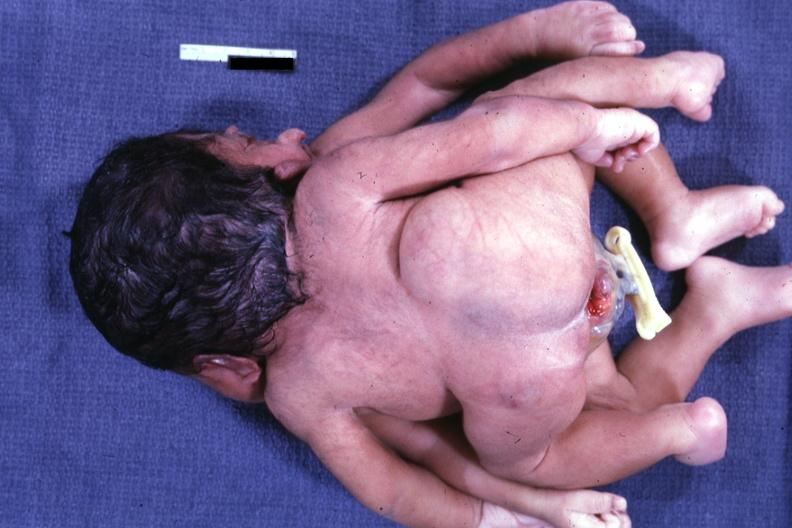s cephalothoracopagus janiceps present?
Answer the question using a single word or phrase. Yes 